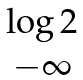Convert formula to latex. <formula><loc_0><loc_0><loc_500><loc_500>\begin{matrix} \log 2 \\ - \infty \end{matrix}</formula> 